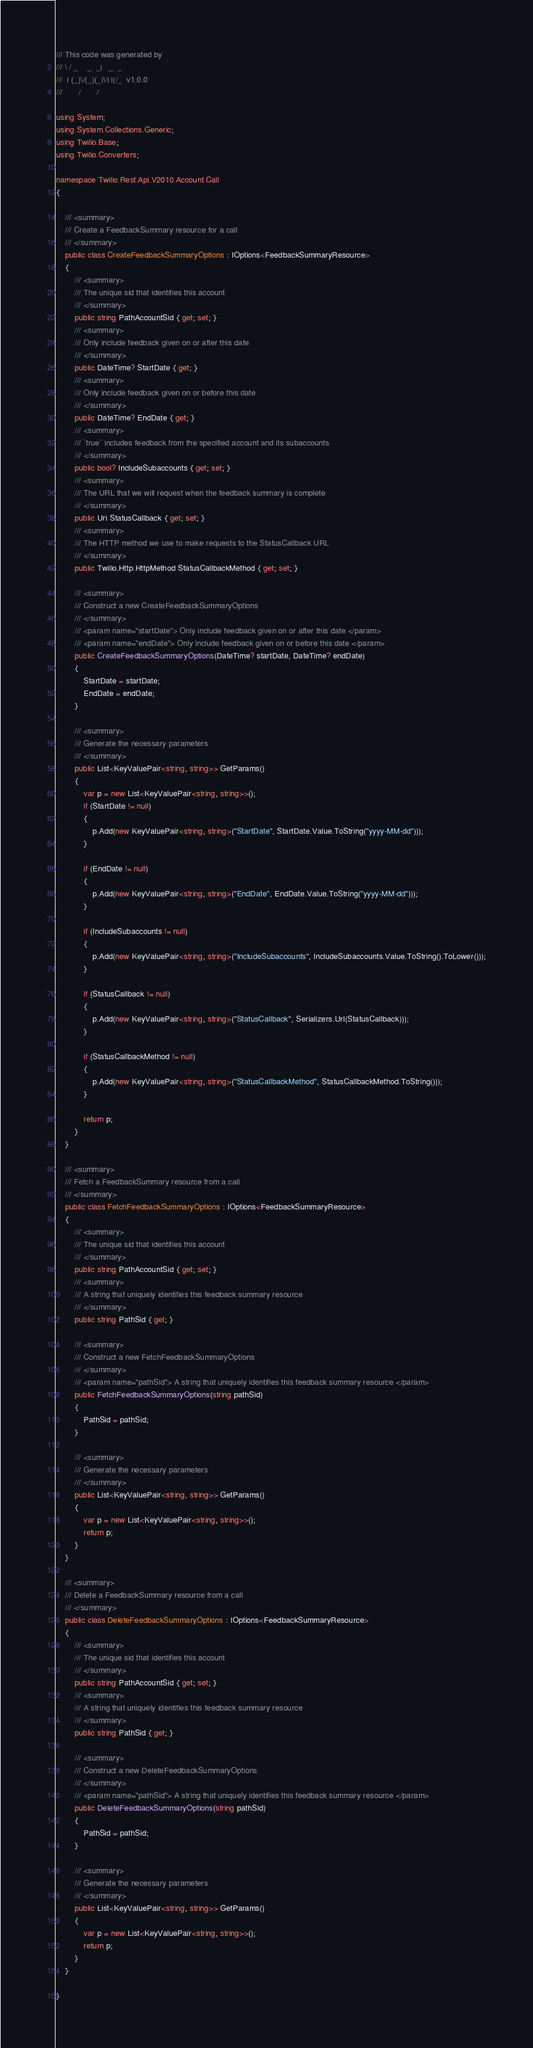Convert code to text. <code><loc_0><loc_0><loc_500><loc_500><_C#_>/// This code was generated by
/// \ / _    _  _|   _  _
///  | (_)\/(_)(_|\/| |(/_  v1.0.0
///       /       /

using System;
using System.Collections.Generic;
using Twilio.Base;
using Twilio.Converters;

namespace Twilio.Rest.Api.V2010.Account.Call
{

    /// <summary>
    /// Create a FeedbackSummary resource for a call
    /// </summary>
    public class CreateFeedbackSummaryOptions : IOptions<FeedbackSummaryResource>
    {
        /// <summary>
        /// The unique sid that identifies this account
        /// </summary>
        public string PathAccountSid { get; set; }
        /// <summary>
        /// Only include feedback given on or after this date
        /// </summary>
        public DateTime? StartDate { get; }
        /// <summary>
        /// Only include feedback given on or before this date
        /// </summary>
        public DateTime? EndDate { get; }
        /// <summary>
        /// `true` includes feedback from the specified account and its subaccounts
        /// </summary>
        public bool? IncludeSubaccounts { get; set; }
        /// <summary>
        /// The URL that we will request when the feedback summary is complete
        /// </summary>
        public Uri StatusCallback { get; set; }
        /// <summary>
        /// The HTTP method we use to make requests to the StatusCallback URL
        /// </summary>
        public Twilio.Http.HttpMethod StatusCallbackMethod { get; set; }

        /// <summary>
        /// Construct a new CreateFeedbackSummaryOptions
        /// </summary>
        /// <param name="startDate"> Only include feedback given on or after this date </param>
        /// <param name="endDate"> Only include feedback given on or before this date </param>
        public CreateFeedbackSummaryOptions(DateTime? startDate, DateTime? endDate)
        {
            StartDate = startDate;
            EndDate = endDate;
        }

        /// <summary>
        /// Generate the necessary parameters
        /// </summary>
        public List<KeyValuePair<string, string>> GetParams()
        {
            var p = new List<KeyValuePair<string, string>>();
            if (StartDate != null)
            {
                p.Add(new KeyValuePair<string, string>("StartDate", StartDate.Value.ToString("yyyy-MM-dd")));
            }

            if (EndDate != null)
            {
                p.Add(new KeyValuePair<string, string>("EndDate", EndDate.Value.ToString("yyyy-MM-dd")));
            }

            if (IncludeSubaccounts != null)
            {
                p.Add(new KeyValuePair<string, string>("IncludeSubaccounts", IncludeSubaccounts.Value.ToString().ToLower()));
            }

            if (StatusCallback != null)
            {
                p.Add(new KeyValuePair<string, string>("StatusCallback", Serializers.Url(StatusCallback)));
            }

            if (StatusCallbackMethod != null)
            {
                p.Add(new KeyValuePair<string, string>("StatusCallbackMethod", StatusCallbackMethod.ToString()));
            }

            return p;
        }
    }

    /// <summary>
    /// Fetch a FeedbackSummary resource from a call
    /// </summary>
    public class FetchFeedbackSummaryOptions : IOptions<FeedbackSummaryResource>
    {
        /// <summary>
        /// The unique sid that identifies this account
        /// </summary>
        public string PathAccountSid { get; set; }
        /// <summary>
        /// A string that uniquely identifies this feedback summary resource
        /// </summary>
        public string PathSid { get; }

        /// <summary>
        /// Construct a new FetchFeedbackSummaryOptions
        /// </summary>
        /// <param name="pathSid"> A string that uniquely identifies this feedback summary resource </param>
        public FetchFeedbackSummaryOptions(string pathSid)
        {
            PathSid = pathSid;
        }

        /// <summary>
        /// Generate the necessary parameters
        /// </summary>
        public List<KeyValuePair<string, string>> GetParams()
        {
            var p = new List<KeyValuePair<string, string>>();
            return p;
        }
    }

    /// <summary>
    /// Delete a FeedbackSummary resource from a call
    /// </summary>
    public class DeleteFeedbackSummaryOptions : IOptions<FeedbackSummaryResource>
    {
        /// <summary>
        /// The unique sid that identifies this account
        /// </summary>
        public string PathAccountSid { get; set; }
        /// <summary>
        /// A string that uniquely identifies this feedback summary resource
        /// </summary>
        public string PathSid { get; }

        /// <summary>
        /// Construct a new DeleteFeedbackSummaryOptions
        /// </summary>
        /// <param name="pathSid"> A string that uniquely identifies this feedback summary resource </param>
        public DeleteFeedbackSummaryOptions(string pathSid)
        {
            PathSid = pathSid;
        }

        /// <summary>
        /// Generate the necessary parameters
        /// </summary>
        public List<KeyValuePair<string, string>> GetParams()
        {
            var p = new List<KeyValuePair<string, string>>();
            return p;
        }
    }

}</code> 